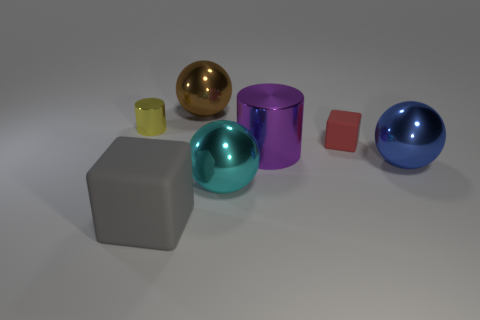How many brown things are either rubber spheres or rubber objects?
Give a very brief answer. 0. Are there more large blue objects than tiny yellow spheres?
Your response must be concise. Yes. There is a thing that is behind the small yellow thing; is it the same size as the object on the right side of the red object?
Provide a short and direct response. Yes. There is a cube on the right side of the rubber object that is in front of the big thing on the right side of the large purple metallic cylinder; what color is it?
Provide a short and direct response. Red. Are there any other tiny yellow objects that have the same shape as the small yellow shiny thing?
Your answer should be very brief. No. Are there more blue balls that are in front of the blue thing than gray blocks?
Make the answer very short. No. How many metallic things are large brown objects or purple blocks?
Ensure brevity in your answer.  1. What size is the metallic object that is behind the purple cylinder and right of the gray matte thing?
Give a very brief answer. Large. Are there any big gray things on the right side of the metal cylinder in front of the small red rubber thing?
Offer a terse response. No. How many cylinders are on the left side of the big gray rubber thing?
Make the answer very short. 1. 